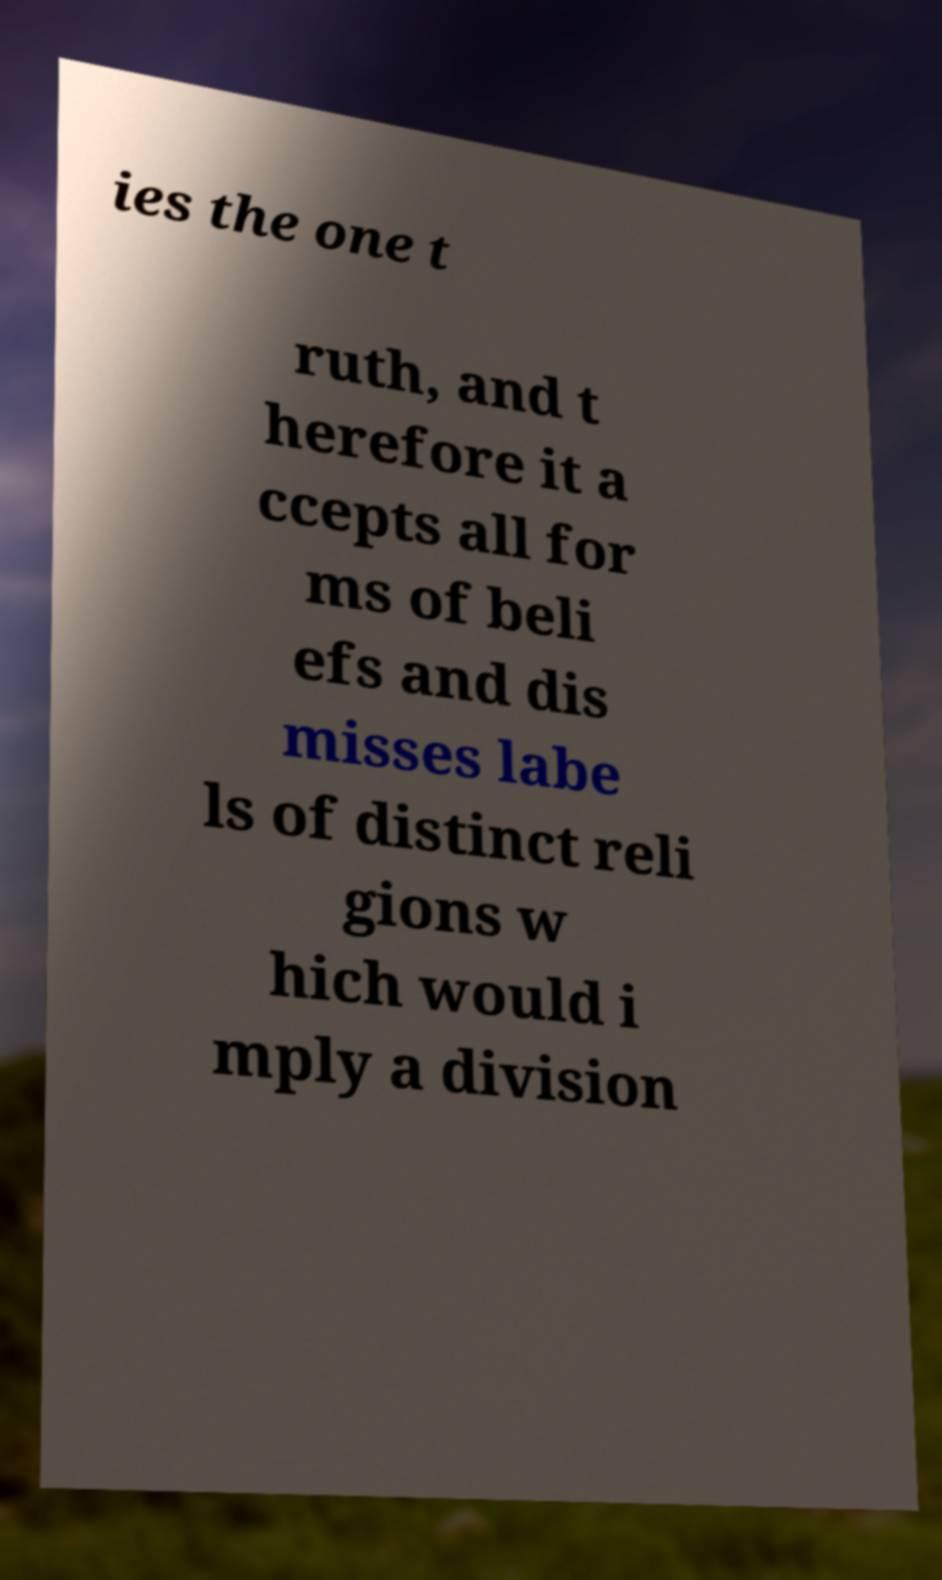For documentation purposes, I need the text within this image transcribed. Could you provide that? ies the one t ruth, and t herefore it a ccepts all for ms of beli efs and dis misses labe ls of distinct reli gions w hich would i mply a division 